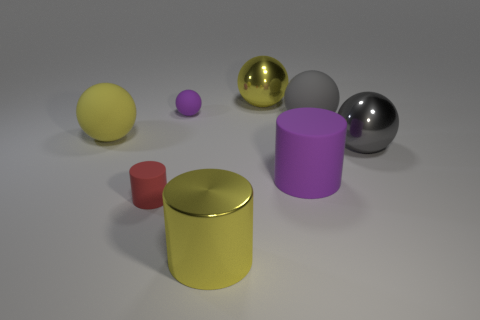What is the color of the rubber cylinder that is to the right of the yellow metal sphere?
Keep it short and to the point. Purple. How many metal things are either green things or large purple cylinders?
Keep it short and to the point. 0. There is a big matte object that is the same color as the tiny rubber ball; what is its shape?
Your answer should be compact. Cylinder. How many cyan cubes are the same size as the yellow rubber thing?
Your answer should be compact. 0. What color is the thing that is both in front of the big rubber cylinder and on the left side of the small purple ball?
Your answer should be very brief. Red. How many things are big yellow spheres or large purple rubber cylinders?
Your response must be concise. 3. How many tiny things are either gray metal spheres or cyan cylinders?
Your response must be concise. 0. Are there any other things that are the same color as the tiny rubber cylinder?
Offer a terse response. No. There is a matte thing that is left of the big gray matte ball and to the right of the big yellow shiny sphere; what is its size?
Your answer should be very brief. Large. Does the object left of the tiny red matte thing have the same color as the big sphere that is behind the big gray rubber ball?
Offer a terse response. Yes. 